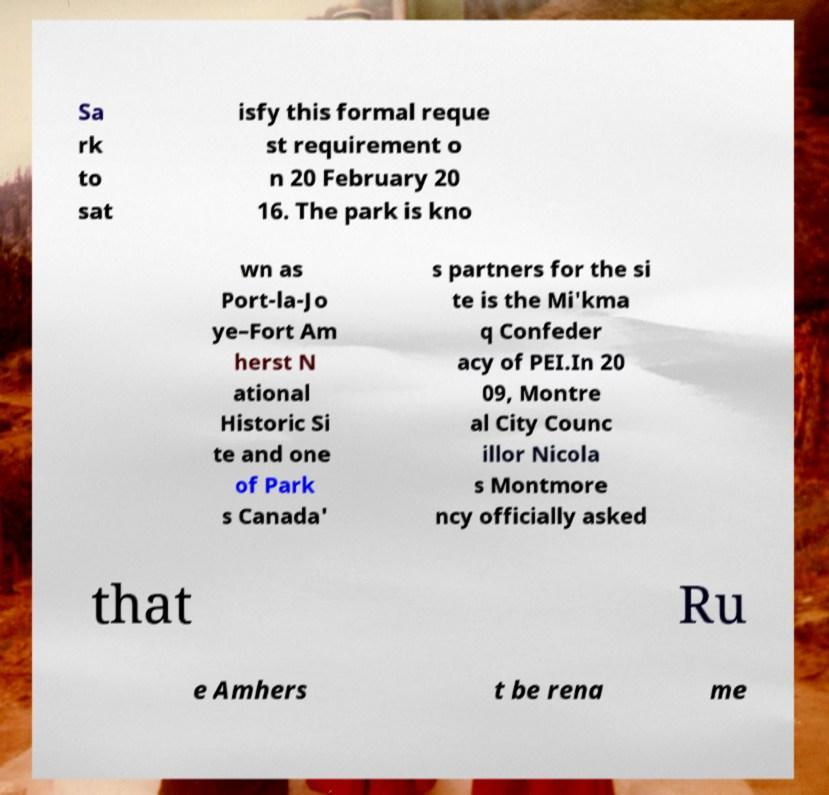I need the written content from this picture converted into text. Can you do that? Sa rk to sat isfy this formal reque st requirement o n 20 February 20 16. The park is kno wn as Port-la-Jo ye–Fort Am herst N ational Historic Si te and one of Park s Canada' s partners for the si te is the Mi'kma q Confeder acy of PEI.In 20 09, Montre al City Counc illor Nicola s Montmore ncy officially asked that Ru e Amhers t be rena me 